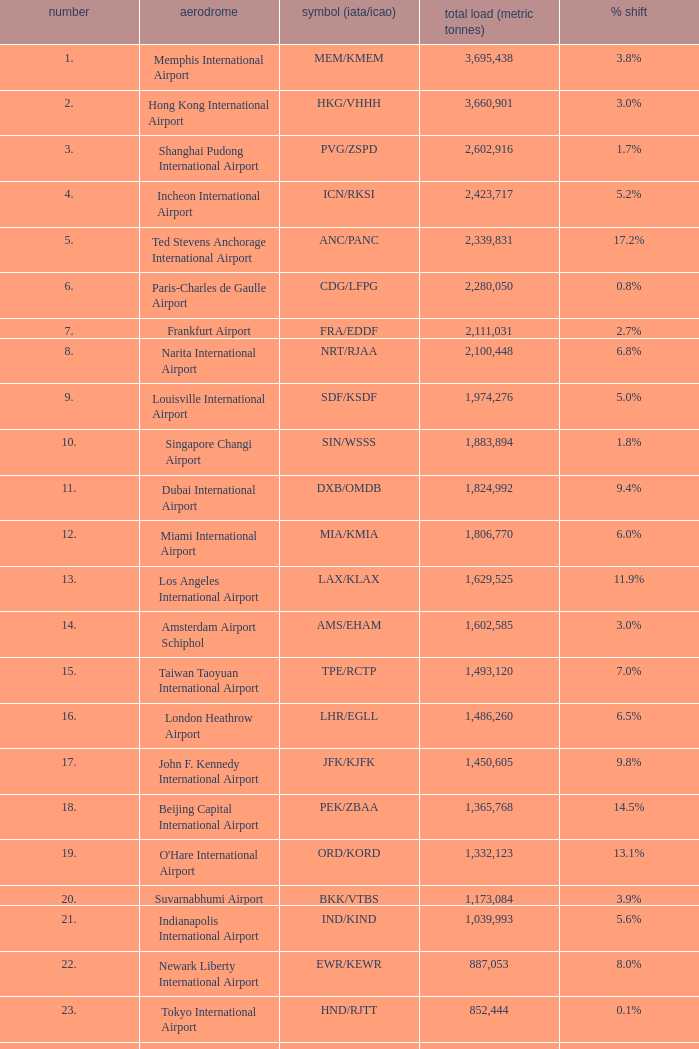What is the code for rank 10? SIN/WSSS. Could you parse the entire table? {'header': ['number', 'aerodrome', 'symbol (iata/icao)', 'total load (metric tonnes)', '% shift'], 'rows': [['1.', 'Memphis International Airport', 'MEM/KMEM', '3,695,438', '3.8%'], ['2.', 'Hong Kong International Airport', 'HKG/VHHH', '3,660,901', '3.0%'], ['3.', 'Shanghai Pudong International Airport', 'PVG/ZSPD', '2,602,916', '1.7%'], ['4.', 'Incheon International Airport', 'ICN/RKSI', '2,423,717', '5.2%'], ['5.', 'Ted Stevens Anchorage International Airport', 'ANC/PANC', '2,339,831', '17.2%'], ['6.', 'Paris-Charles de Gaulle Airport', 'CDG/LFPG', '2,280,050', '0.8%'], ['7.', 'Frankfurt Airport', 'FRA/EDDF', '2,111,031', '2.7%'], ['8.', 'Narita International Airport', 'NRT/RJAA', '2,100,448', '6.8%'], ['9.', 'Louisville International Airport', 'SDF/KSDF', '1,974,276', '5.0%'], ['10.', 'Singapore Changi Airport', 'SIN/WSSS', '1,883,894', '1.8%'], ['11.', 'Dubai International Airport', 'DXB/OMDB', '1,824,992', '9.4%'], ['12.', 'Miami International Airport', 'MIA/KMIA', '1,806,770', '6.0%'], ['13.', 'Los Angeles International Airport', 'LAX/KLAX', '1,629,525', '11.9%'], ['14.', 'Amsterdam Airport Schiphol', 'AMS/EHAM', '1,602,585', '3.0%'], ['15.', 'Taiwan Taoyuan International Airport', 'TPE/RCTP', '1,493,120', '7.0%'], ['16.', 'London Heathrow Airport', 'LHR/EGLL', '1,486,260', '6.5%'], ['17.', 'John F. Kennedy International Airport', 'JFK/KJFK', '1,450,605', '9.8%'], ['18.', 'Beijing Capital International Airport', 'PEK/ZBAA', '1,365,768', '14.5%'], ['19.', "O'Hare International Airport", 'ORD/KORD', '1,332,123', '13.1%'], ['20.', 'Suvarnabhumi Airport', 'BKK/VTBS', '1,173,084', '3.9%'], ['21.', 'Indianapolis International Airport', 'IND/KIND', '1,039,993', '5.6%'], ['22.', 'Newark Liberty International Airport', 'EWR/KEWR', '887,053', '8.0%'], ['23.', 'Tokyo International Airport', 'HND/RJTT', '852,444', '0.1%'], ['24.', 'Kansai International Airport', 'KIX/RJBB', '845,497', '0.1%'], ['25.', 'Luxembourg-Findel Airport', 'LUX/ELLX', '788,224', '8.0%'], ['26.', 'Guangzhou Baiyun International Airport', 'CAN/ZGGG', '685,868', '1.3%'], ['27.', 'Kuala Lumpur International Airport', 'KUL/WMKK', '667,495', '2.2%'], ['28.', 'Dallas-Fort Worth International Airport', 'DFW/KDFW', '660,036', '8.7%'], ['29.', 'Brussels Airport', 'BRU/EBBR', '659,054', '11.8%'], ['30.', 'Hartsfield-Jackson Atlanta International Airport', 'ATL/KATL', '655,277', '9.0%']]} 